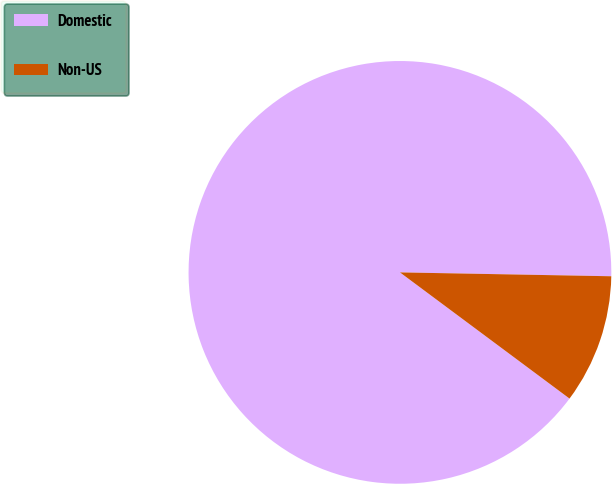<chart> <loc_0><loc_0><loc_500><loc_500><pie_chart><fcel>Domestic<fcel>Non-US<nl><fcel>90.11%<fcel>9.89%<nl></chart> 